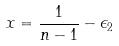<formula> <loc_0><loc_0><loc_500><loc_500>x = \frac { 1 } { n - 1 } - \epsilon _ { 2 }</formula> 